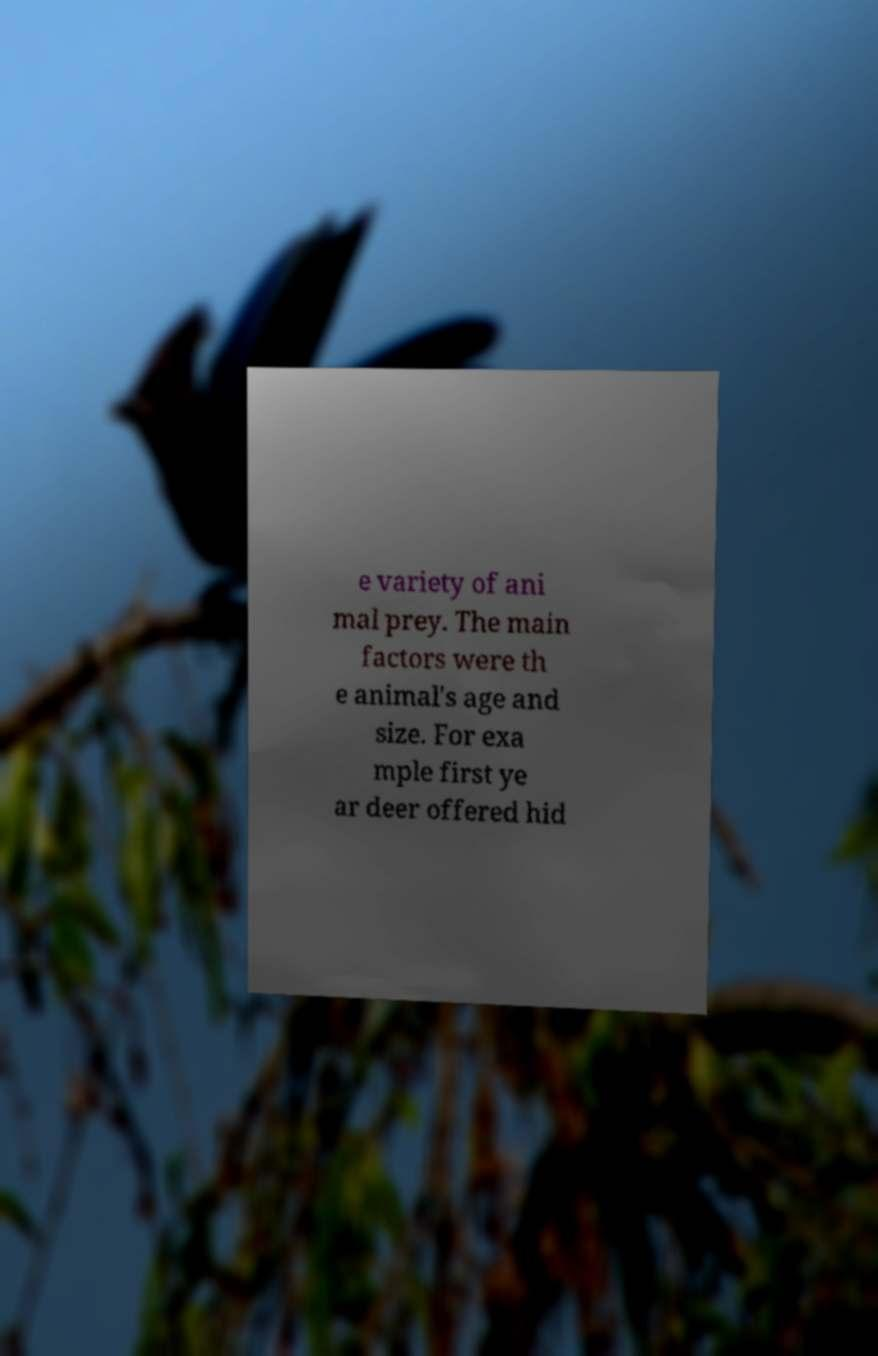Please identify and transcribe the text found in this image. e variety of ani mal prey. The main factors were th e animal's age and size. For exa mple first ye ar deer offered hid 